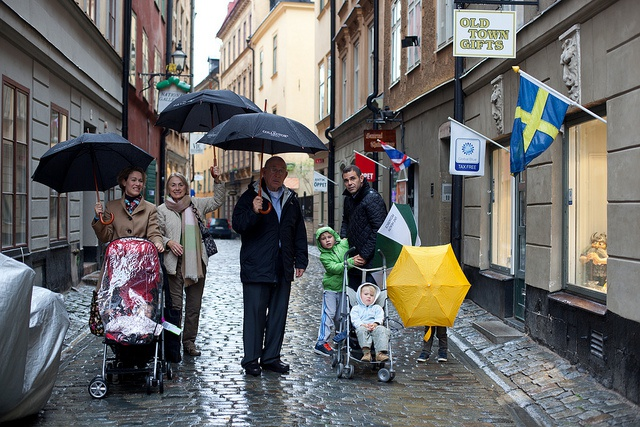Describe the objects in this image and their specific colors. I can see people in black, maroon, and gray tones, umbrella in black, gray, and blue tones, umbrella in black, orange, gold, and olive tones, people in black, darkgray, and gray tones, and people in black, gray, and darkgray tones in this image. 